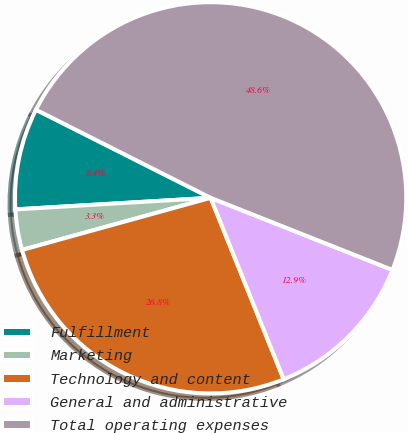Convert chart. <chart><loc_0><loc_0><loc_500><loc_500><pie_chart><fcel>Fulfillment<fcel>Marketing<fcel>Technology and content<fcel>General and administrative<fcel>Total operating expenses<nl><fcel>8.38%<fcel>3.35%<fcel>26.8%<fcel>12.9%<fcel>48.58%<nl></chart> 